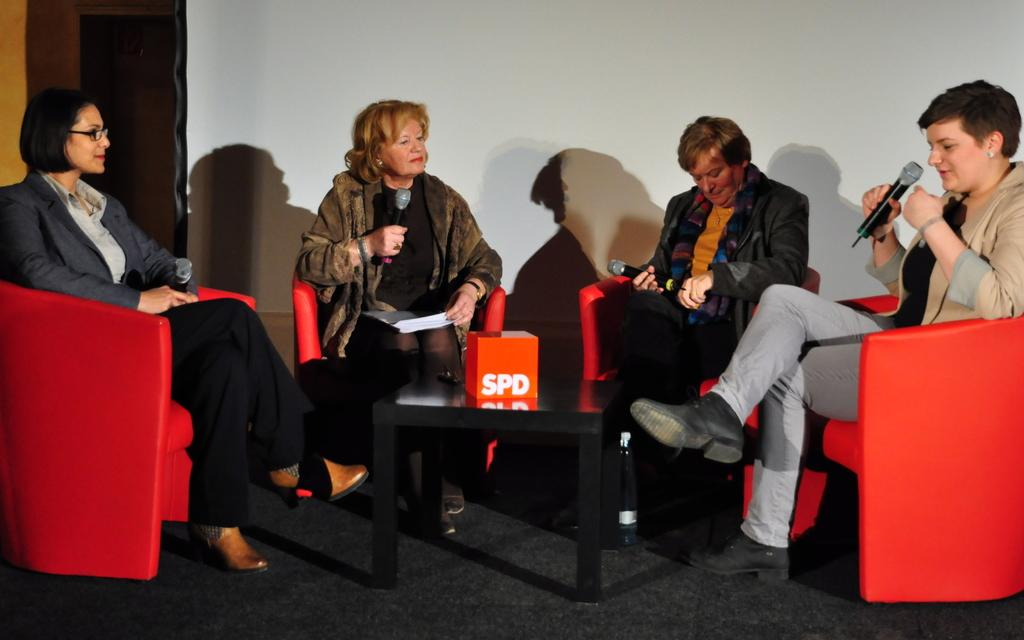How many women are present in the image? There are four women in the image. What are the women sitting on? The women are sitting on red chairs. What are the women holding in their hands? Each woman is holding a microphone. Can you describe the table in the image? There is a small table in the image. What color is the object on the table? There is an orange-colored object on the table. What type of alarm can be heard going off in the image? There is no alarm present or audible in the image. Can you see a cat sitting on the table in the image? There is no cat present in the image. 